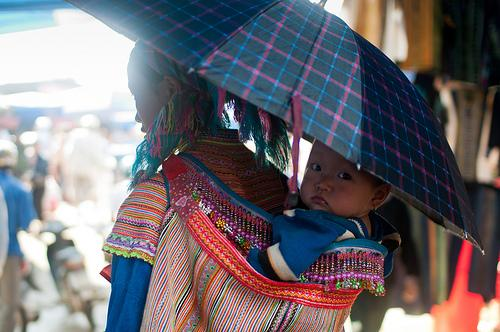Provide a concise description of the image while emphasizing the subjects and their actions. A colorfully dressed woman carries her baby on her back under a plaid umbrella while faint hints of light surround them. Mention any clothing or accessories the primary subjects in the image are wearing. The mother wears a colorful scarf and a shawl, while the baby dons a blue outfit, and they're under a plaid umbrella. Describe the image, giving attention to details like the colors and textures. An image of a mother and child, with the mother in vibrant apparel and the baby in blue, under a bright, plaid umbrella. Describe the scene in regards to the weather conditions and the subjects' attire to protect themselves. The scene suggests possible rain, as a woman and her baby shelter under a plaid umbrella, with the mother wearing a scarf and shawl. What is the central theme of the image, and how is it portrayed? The mother-child bond is the central theme of the image, portrayed by the close proximity of the mother carrying her baby under an umbrella. Provide a brief summary of the image focusing on the most prominent elements. A woman wearing a colorful scarf is carrying a baby on her back in a beaded baby carrier, both under a plaid umbrella. Explain the relationship between the subjects in the image. A mother has her baby in a baby carrier on her back, as they both stay protected under a colorful umbrella. Characterize the baby and the device they're carried in within the image. A baby wearing a blue outfit is nestled inside a colorful, beaded baby carrier attached to its mother's back. Highlight the main objects and colors in the image. The image features a mother, her baby, a beaded baby carrier, and a plaid umbrella, surrounded by hints of bright light. Describe the visual setting surrounding the primary subjects of the image. The woman and baby are surrounded by blurry shades of bright light and a few indistinct objects placed in the background. 